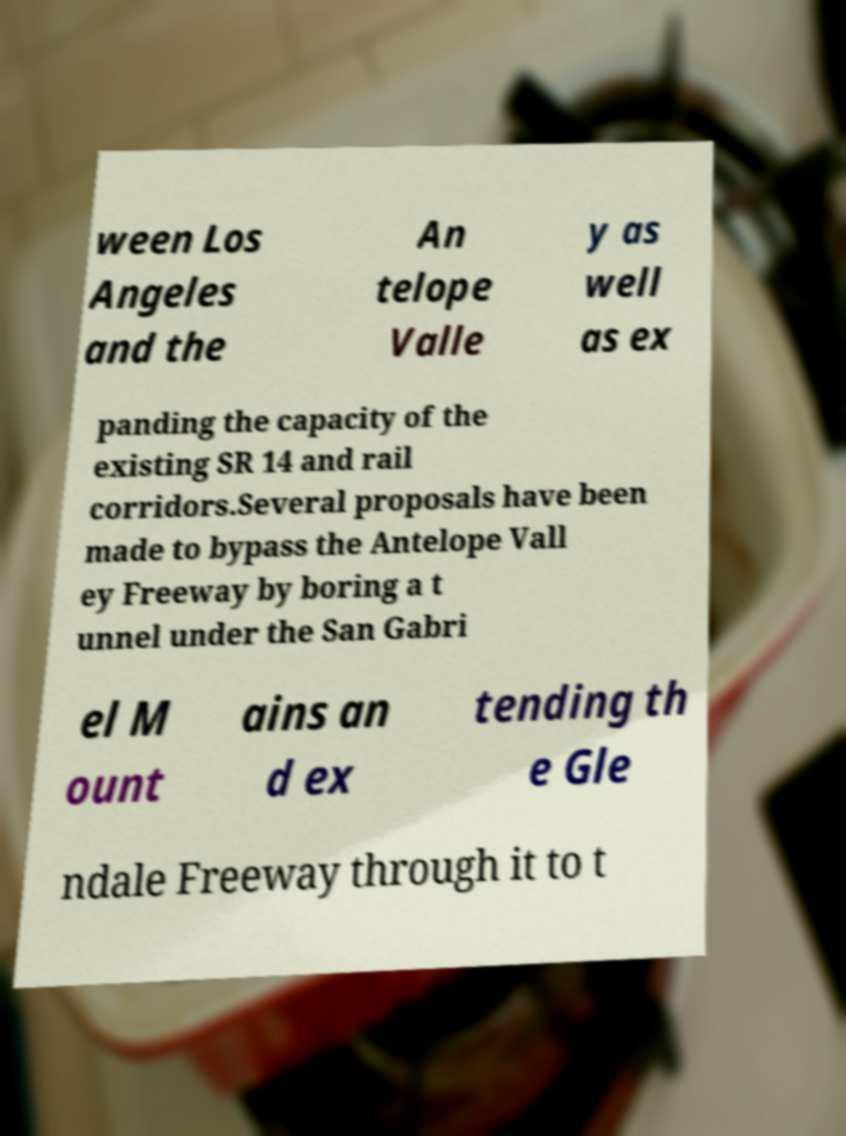Can you accurately transcribe the text from the provided image for me? ween Los Angeles and the An telope Valle y as well as ex panding the capacity of the existing SR 14 and rail corridors.Several proposals have been made to bypass the Antelope Vall ey Freeway by boring a t unnel under the San Gabri el M ount ains an d ex tending th e Gle ndale Freeway through it to t 